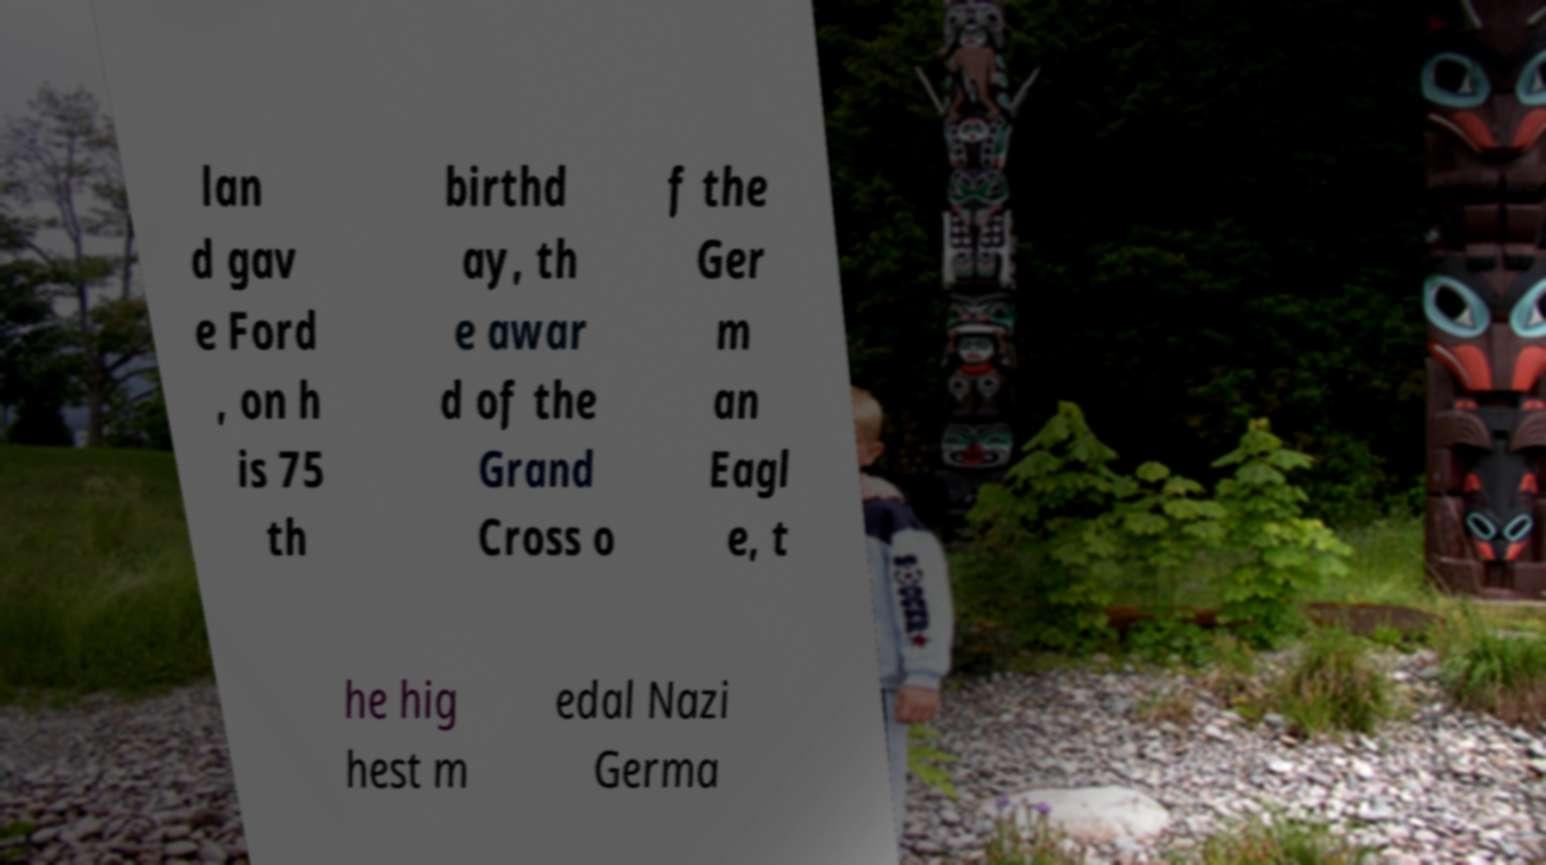Please identify and transcribe the text found in this image. lan d gav e Ford , on h is 75 th birthd ay, th e awar d of the Grand Cross o f the Ger m an Eagl e, t he hig hest m edal Nazi Germa 